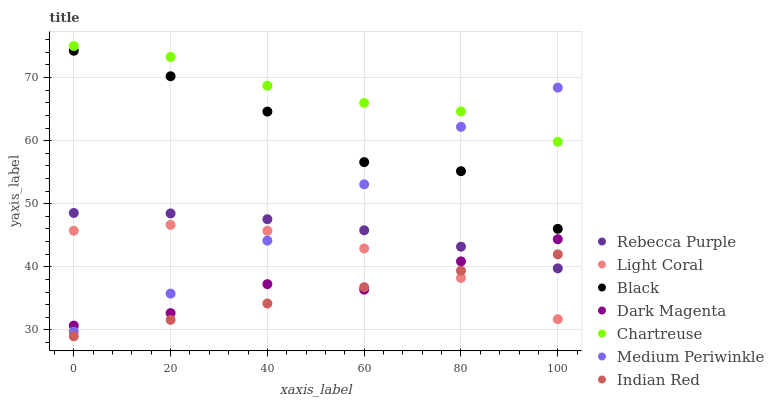Does Indian Red have the minimum area under the curve?
Answer yes or no. Yes. Does Chartreuse have the maximum area under the curve?
Answer yes or no. Yes. Does Medium Periwinkle have the minimum area under the curve?
Answer yes or no. No. Does Medium Periwinkle have the maximum area under the curve?
Answer yes or no. No. Is Indian Red the smoothest?
Answer yes or no. Yes. Is Black the roughest?
Answer yes or no. Yes. Is Medium Periwinkle the smoothest?
Answer yes or no. No. Is Medium Periwinkle the roughest?
Answer yes or no. No. Does Indian Red have the lowest value?
Answer yes or no. Yes. Does Medium Periwinkle have the lowest value?
Answer yes or no. No. Does Chartreuse have the highest value?
Answer yes or no. Yes. Does Medium Periwinkle have the highest value?
Answer yes or no. No. Is Rebecca Purple less than Black?
Answer yes or no. Yes. Is Chartreuse greater than Light Coral?
Answer yes or no. Yes. Does Black intersect Medium Periwinkle?
Answer yes or no. Yes. Is Black less than Medium Periwinkle?
Answer yes or no. No. Is Black greater than Medium Periwinkle?
Answer yes or no. No. Does Rebecca Purple intersect Black?
Answer yes or no. No. 